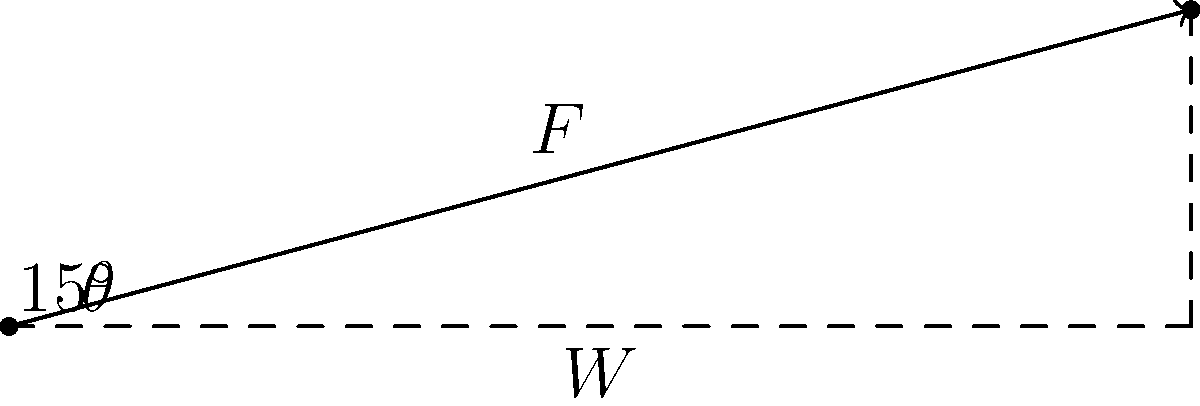As a parent, you're pushing a stroller up a gentle slope in the park. The combined weight of the stroller and child is 25 kg, and the incline is at a 15° angle. Assuming friction is negligible, what force (in Newtons) do you need to apply parallel to the slope to keep the stroller moving at a constant speed? To solve this problem, we'll follow these steps:

1) First, we need to calculate the weight force:
   $W = mg$, where $m$ is the mass and $g$ is the acceleration due to gravity (9.8 m/s²)
   $W = 25 \text{ kg} \times 9.8 \text{ m/s}^2 = 245 \text{ N}$

2) The force needed to push the stroller up the slope is equal to the component of the weight force parallel to the slope:
   $F = W \sin \theta$

3) We're given that $\theta = 15°$. Let's calculate $\sin 15°$:
   $\sin 15° \approx 0.2588$

4) Now we can calculate the required force:
   $F = 245 \text{ N} \times 0.2588 \approx 63.41 \text{ N}$

This force represents the effort you need to exert to keep the stroller moving at a constant speed up the incline, counteracting the component of gravity pulling it back down the slope.
Answer: 63.41 N 